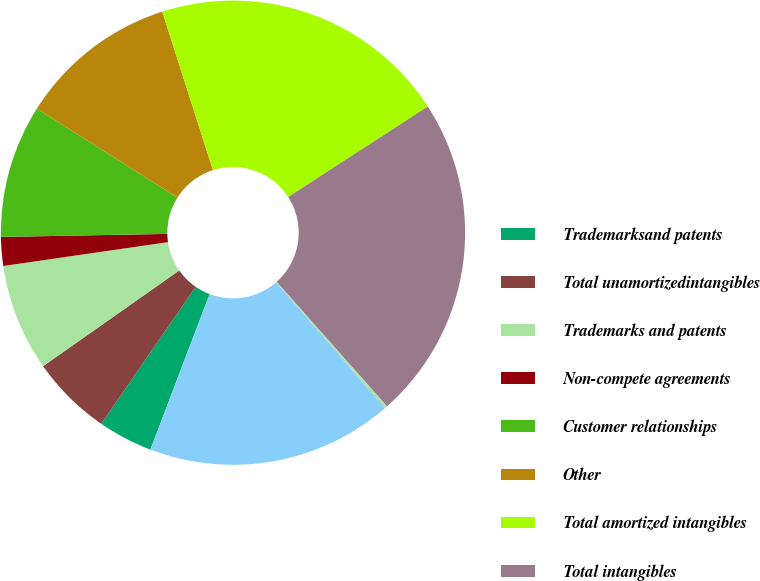<chart> <loc_0><loc_0><loc_500><loc_500><pie_chart><fcel>Trademarksand patents<fcel>Total unamortizedintangibles<fcel>Trademarks and patents<fcel>Non-compete agreements<fcel>Customer relationships<fcel>Other<fcel>Total amortized intangibles<fcel>Total intangibles<fcel>Total unamortized intangibles<fcel>Total amortizedintangibles<nl><fcel>3.82%<fcel>5.64%<fcel>7.46%<fcel>2.0%<fcel>9.27%<fcel>11.09%<fcel>20.78%<fcel>22.6%<fcel>0.19%<fcel>17.15%<nl></chart> 